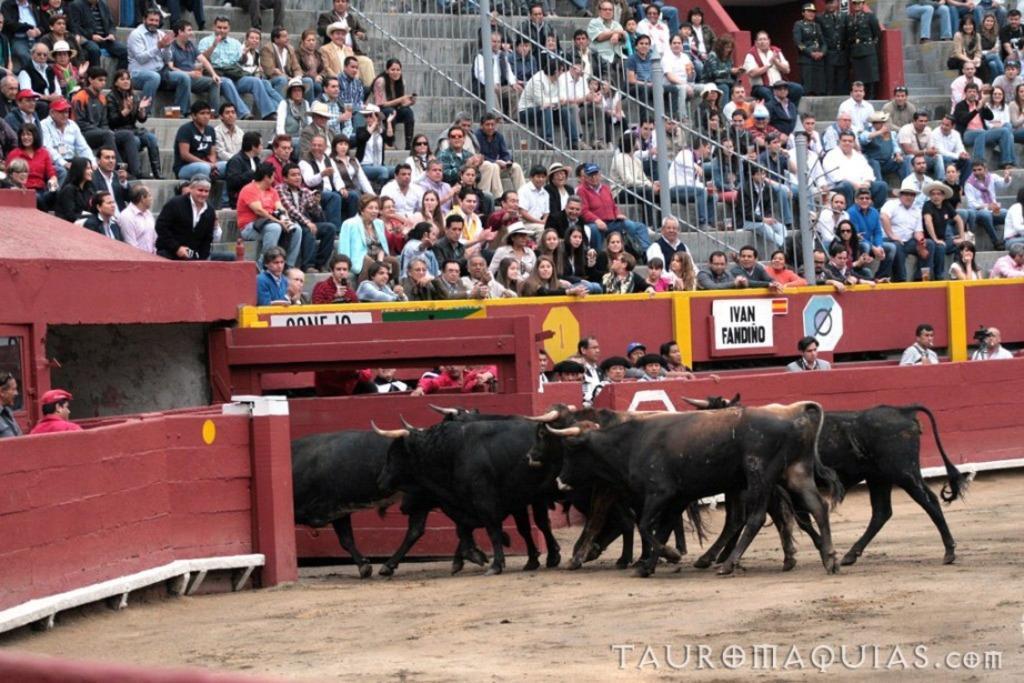Please provide a concise description of this image. In this image we can see some bulls on the ground and some people sitting on the steps and there are three security guards standing behind and wooden fence with a gate. 